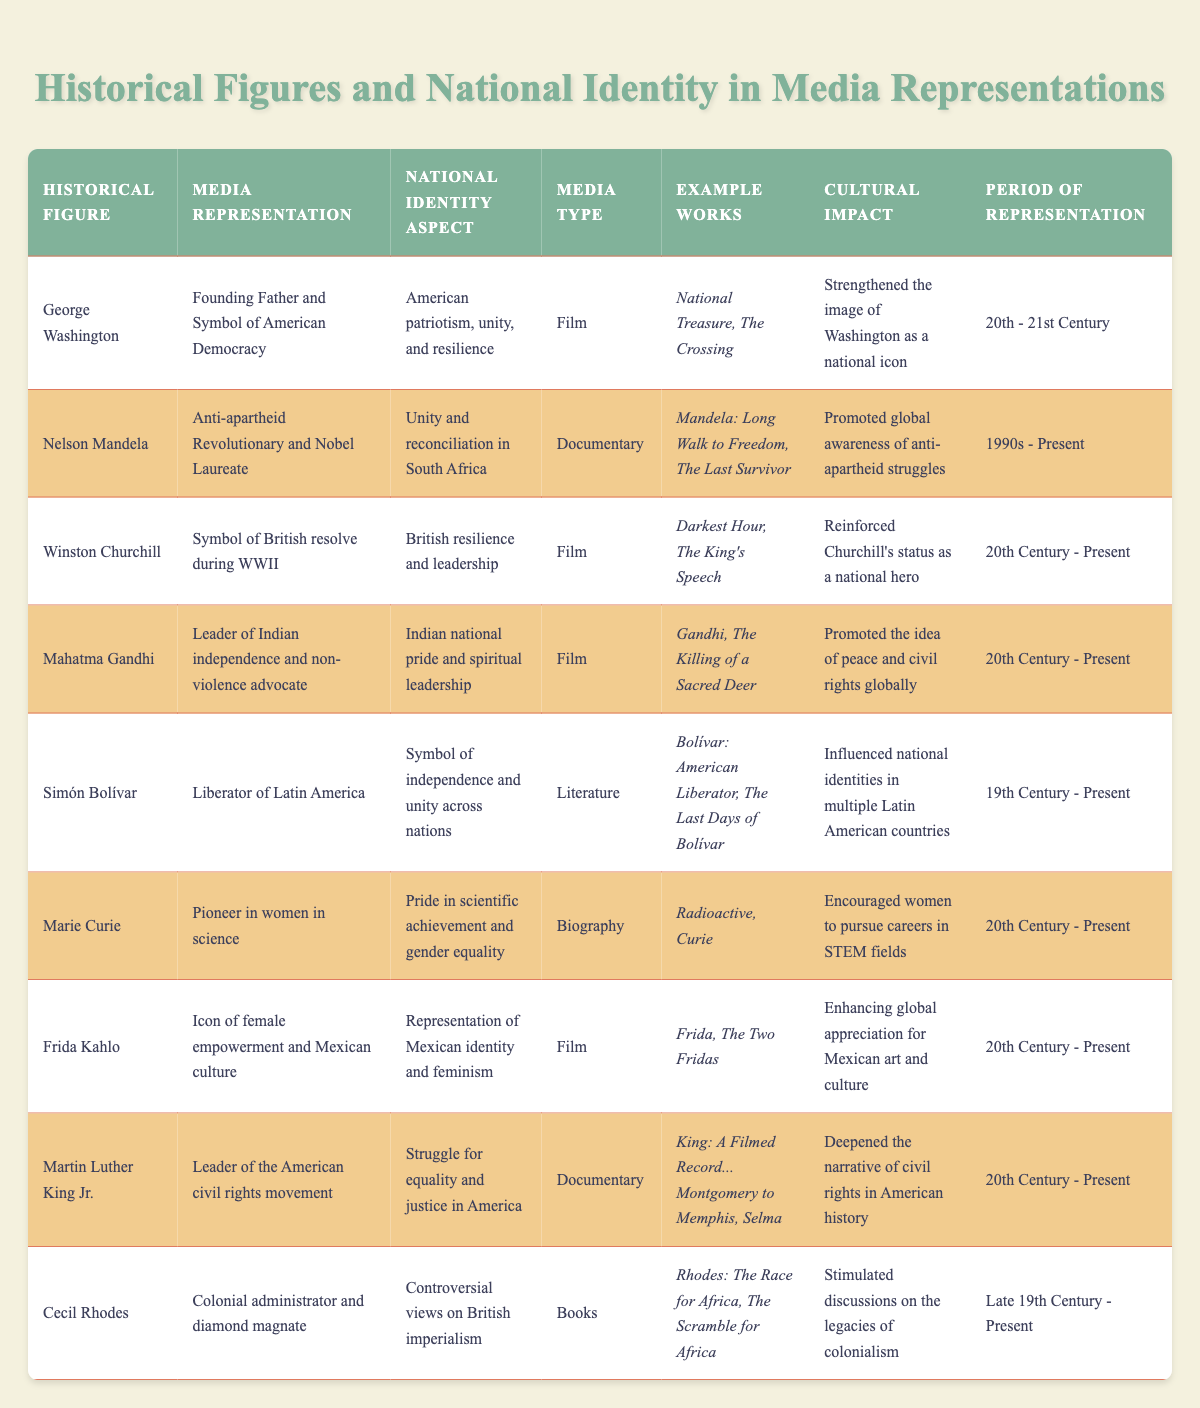What is the cultural impact of Nelson Mandela's media representation? The cultural impact of Nelson Mandela's media representation is that it promoted global awareness of anti-apartheid struggles. This information is directly stated in the table under the "Cultural Impact" column for Nelson Mandela.
Answer: Promoted global awareness of anti-apartheid struggles Which historical figure is associated with the media representation of being a 'symbol of British resolve during WWII'? The table lists Winston Churchill as the historical figure with the media representation of being a 'symbol of British resolve during WWII', which can be found in the "Media Representation" column.
Answer: Winston Churchill How many historical figures are represented in film media type? By reviewing the "Media Type" column, we find that George Washington, Winston Churchill, Mahatma Gandhi, Frida Kahlo, and Martin Luther King Jr. are all depicted in film. Therefore, there are 5 film representations in total.
Answer: 5 Which media representation emphasizes Indian national pride? The media representation that emphasizes Indian national pride is Mahatma Gandhi, identified in the "Media Representation" column.
Answer: Mahatma Gandhi Is there a media representation that has influenced national identities in multiple Latin American countries? Yes, Simón Bolívar's media representation as the 'Liberator of Latin America' has influenced national identities in multiple Latin American countries, as stated in the table.
Answer: Yes What is the period of representation for Frida Kahlo? The period of representation for Frida Kahlo is specified as "20th Century - Present" in the table. This information can be found in the corresponding column for her.
Answer: 20th Century - Present How does George Washington's representation in media relate to American identity? George Washington's representation in media relates to American identity by reinforcing the aspects of American patriotism, unity, and resilience, as detailed in the "National Identity Aspect" column.
Answer: American patriotism, unity, and resilience Who is identified as a pioneer in women in science among these historical figures? The table identifies Marie Curie as the pioneer in women in science, noted in her "Media Representation" row within the table.
Answer: Marie Curie How many historical figures are associated with documentaries as their media type? By counting the rows that list "Documentary" under the "Media Type" column, we find that there are 3 historical figures: Nelson Mandela, Martin Luther King Jr., and Winston Churchill.
Answer: 3 What aspect of national identity is emphasized by Mahatma Gandhi's media representation? Mahatma Gandhi's media representation emphasizes Indian national pride and spiritual leadership, which is clearly stated in the "National Identity Aspect" column of the table.
Answer: Indian national pride and spiritual leadership 